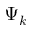Convert formula to latex. <formula><loc_0><loc_0><loc_500><loc_500>\Psi _ { k }</formula> 